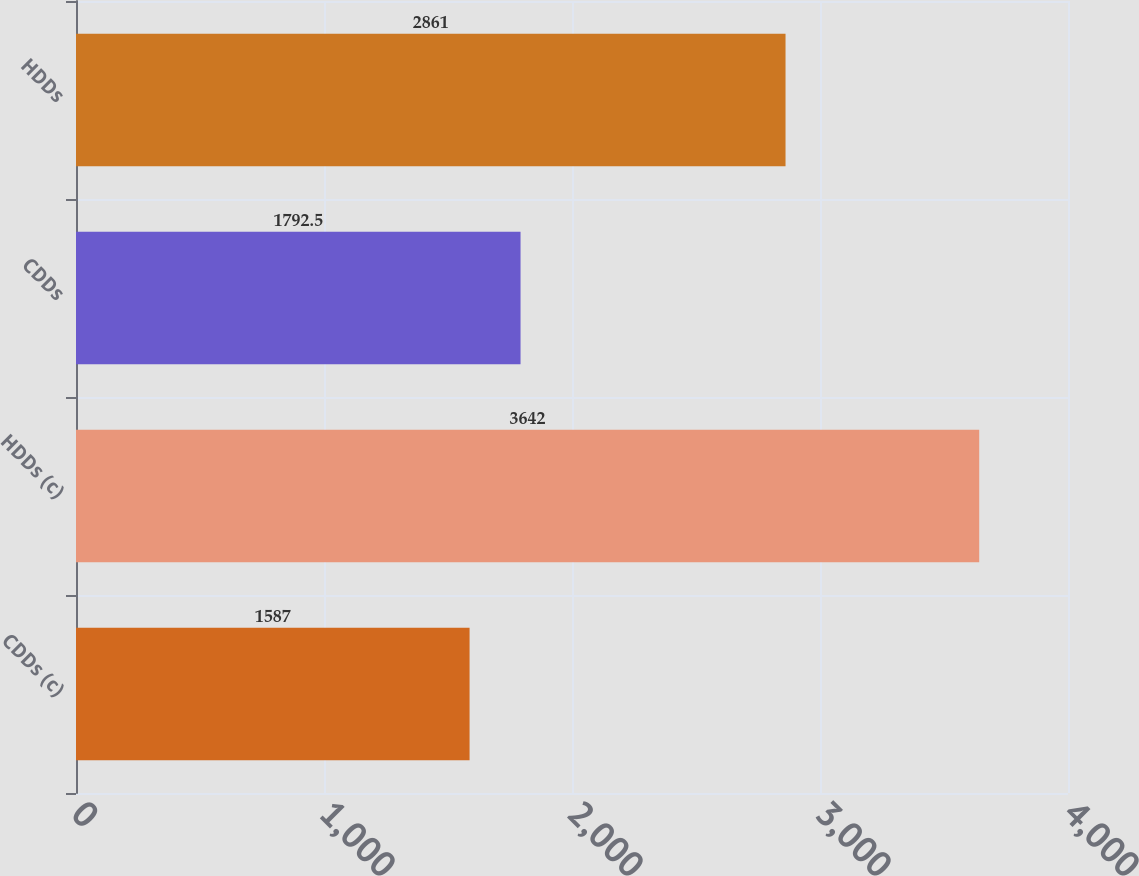Convert chart to OTSL. <chart><loc_0><loc_0><loc_500><loc_500><bar_chart><fcel>CDDs (c)<fcel>HDDs (c)<fcel>CDDs<fcel>HDDs<nl><fcel>1587<fcel>3642<fcel>1792.5<fcel>2861<nl></chart> 